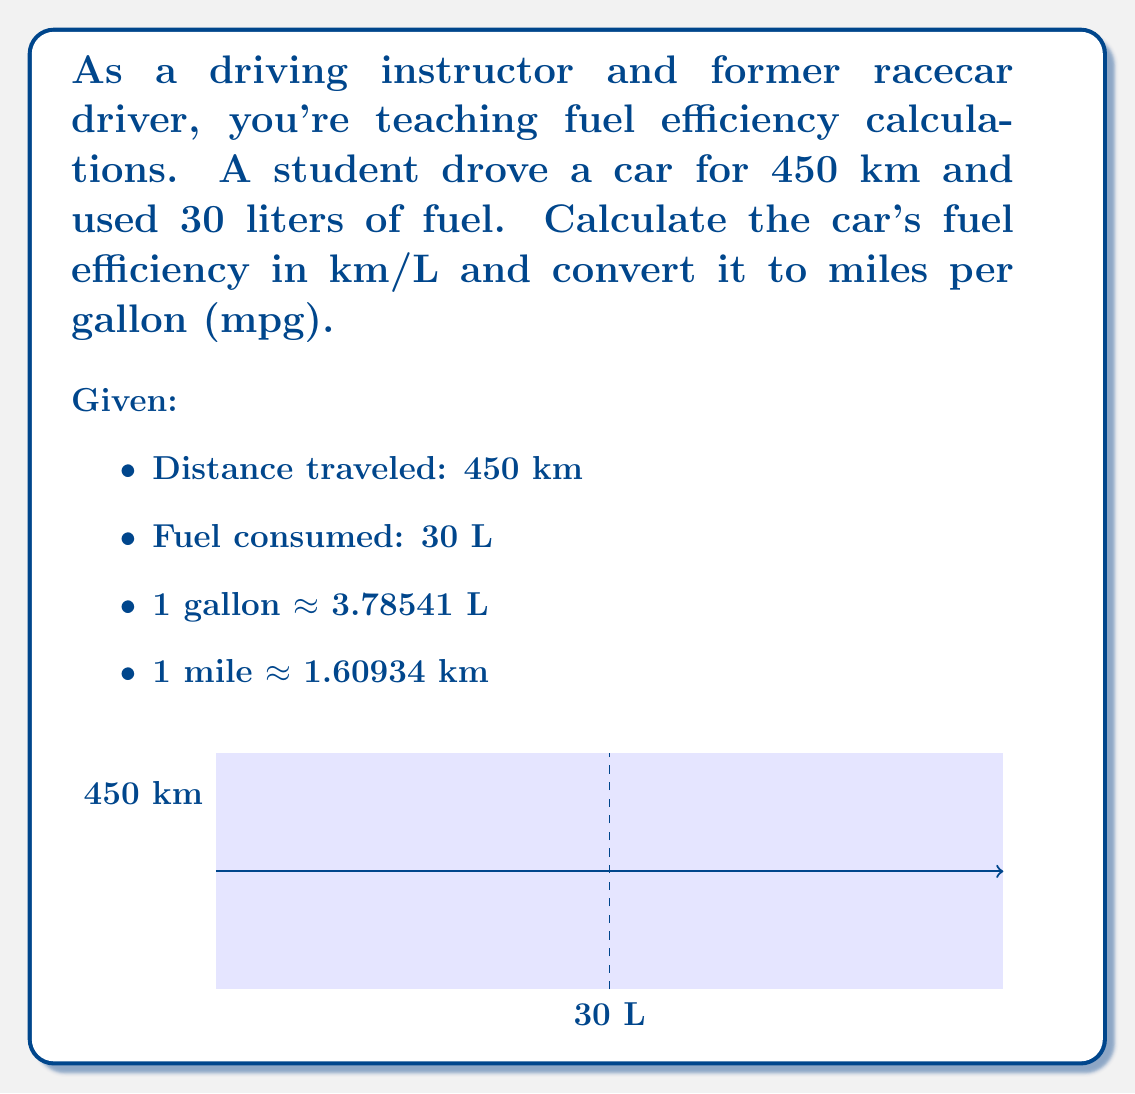What is the answer to this math problem? Let's solve this problem step by step:

1. Calculate fuel efficiency in km/L:
   $$ \text{Fuel Efficiency} = \frac{\text{Distance Traveled}}{\text{Fuel Consumed}} $$
   $$ \text{Fuel Efficiency} = \frac{450 \text{ km}}{30 \text{ L}} = 15 \text{ km/L} $$

2. Convert km/L to mpg:
   a) First, convert km to miles:
      $$ 15 \frac{\text{km}}{\text{L}} \times \frac{1 \text{ mile}}{1.60934 \text{ km}} = 9.32 \frac{\text{miles}}{\text{L}} $$
   
   b) Then, convert L to gallons:
      $$ 9.32 \frac{\text{miles}}{\text{L}} \times \frac{3.78541 \text{ L}}{1 \text{ gallon}} = 35.28 \frac{\text{miles}}{\text{gallon}} $$

3. Round the result to two decimal places:
   $$ 35.28 \text{ mpg} \approx 35.28 \text{ mpg} $$
Answer: 15 km/L or 35.28 mpg 